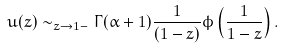<formula> <loc_0><loc_0><loc_500><loc_500>u ( z ) \sim _ { z \to 1 - } \Gamma ( \alpha + 1 ) \frac { 1 } { ( 1 - z ) } \phi \left ( \frac { 1 } { 1 - z } \right ) .</formula> 